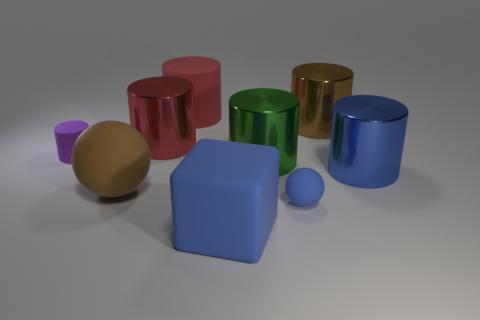Subtract all green cylinders. How many cylinders are left? 5 Subtract all blue cylinders. How many cylinders are left? 5 Subtract all yellow cylinders. Subtract all brown spheres. How many cylinders are left? 6 Add 1 big shiny cylinders. How many objects exist? 10 Subtract all blocks. How many objects are left? 8 Add 9 blue balls. How many blue balls are left? 10 Add 2 small purple metal things. How many small purple metal things exist? 2 Subtract 0 cyan cylinders. How many objects are left? 9 Subtract all tiny green rubber spheres. Subtract all blocks. How many objects are left? 8 